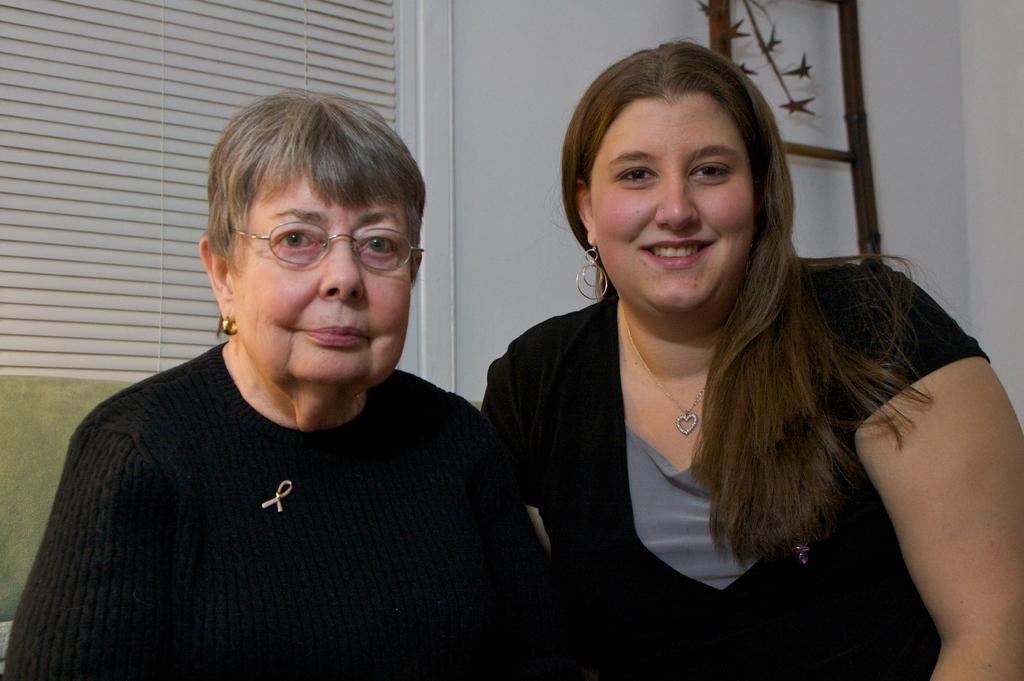Could you give a brief overview of what you see in this image? In this image there are two women who are one beside the other. Behind them there is a curtain. On the right side it looks like a ladder. 